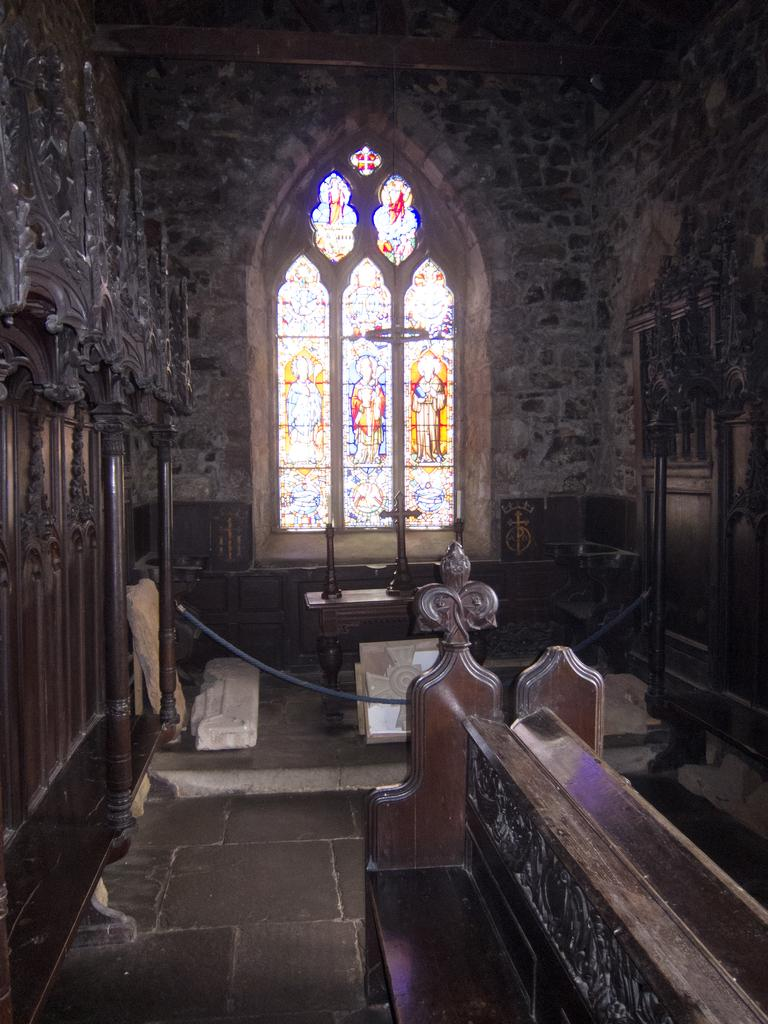What type of setting is depicted in the image? The image shows an interior view of a building. What furniture is present in the image? There is a bench and a table in the image. What architectural feature can be seen in the image? There is a window with a design in the image. How many pots are visible in the image? There are no pots visible in the image. What type of trees can be seen through the window in the image? There are no trees visible through the window in the image. 